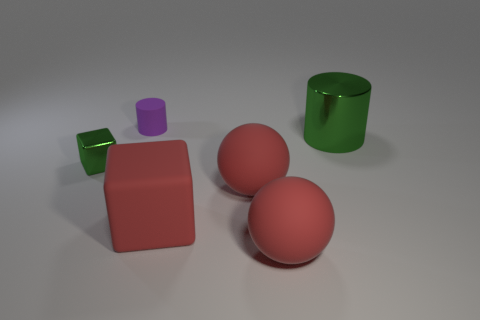Add 2 large red matte things. How many objects exist? 8 Subtract all balls. How many objects are left? 4 Add 2 large metal things. How many large metal things exist? 3 Subtract 0 brown cubes. How many objects are left? 6 Subtract all green shiny blocks. Subtract all metal things. How many objects are left? 3 Add 3 small purple matte things. How many small purple matte things are left? 4 